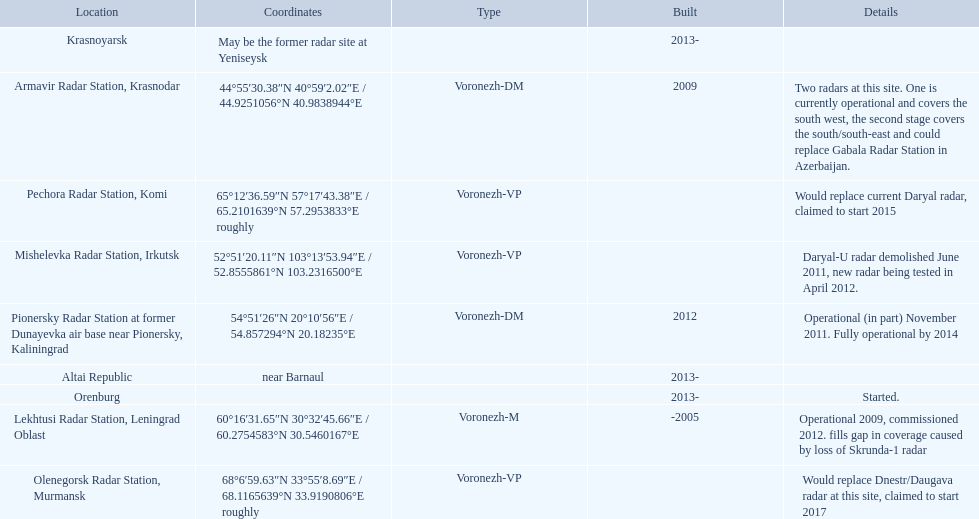What are all of the locations? Lekhtusi Radar Station, Leningrad Oblast, Armavir Radar Station, Krasnodar, Pionersky Radar Station at former Dunayevka air base near Pionersky, Kaliningrad, Mishelevka Radar Station, Irkutsk, Pechora Radar Station, Komi, Olenegorsk Radar Station, Murmansk, Krasnoyarsk, Altai Republic, Orenburg. And which location's coordinates are 60deg16'31.65''n 30deg32'45.66''e / 60.2754583degn 30.5460167dege? Lekhtusi Radar Station, Leningrad Oblast. 